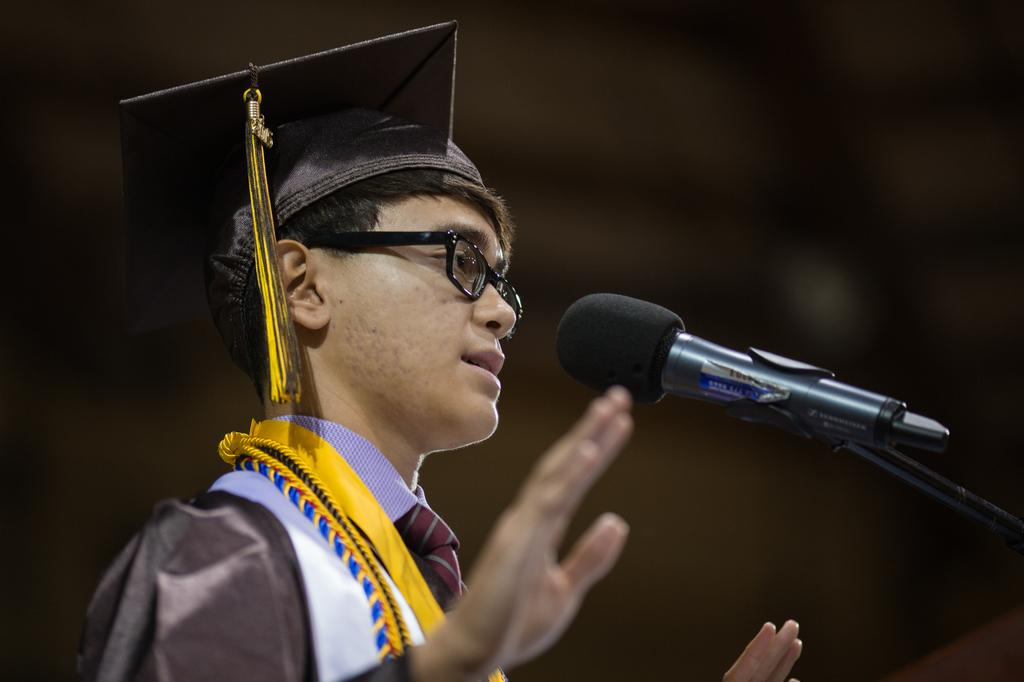What is the main subject of the image? The main subject of the image is a man. What is the man wearing in the image? The man is wearing a shirt and a cap on his head. Does the man have any special items in the image? Yes, the man has medals. What is the man doing in the image? The man is speaking into a microphone and looking towards the right side. What is the man's monthly income in the image? There is no information about the man's income in the image. What causes the shock in the image? There is no shock or any indication of a shocking event in the image. 